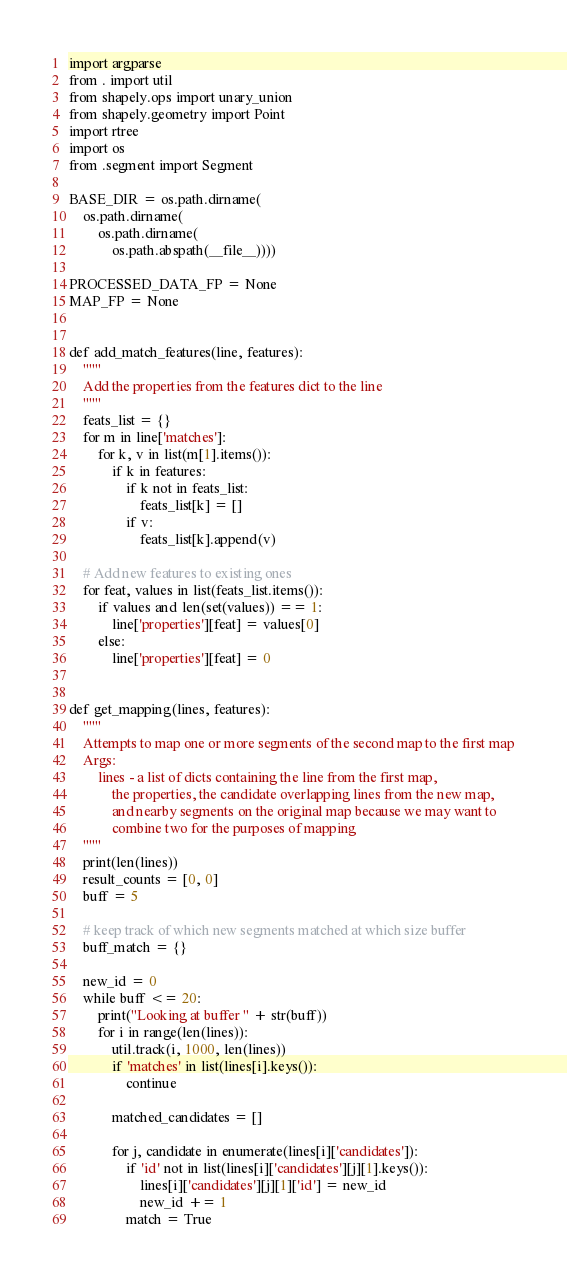<code> <loc_0><loc_0><loc_500><loc_500><_Python_>import argparse
from . import util
from shapely.ops import unary_union
from shapely.geometry import Point
import rtree
import os
from .segment import Segment

BASE_DIR = os.path.dirname(
    os.path.dirname(
        os.path.dirname(
            os.path.abspath(__file__))))

PROCESSED_DATA_FP = None
MAP_FP = None


def add_match_features(line, features):
    """
    Add the properties from the features dict to the line
    """
    feats_list = {}
    for m in line['matches']:
        for k, v in list(m[1].items()):
            if k in features:
                if k not in feats_list:
                    feats_list[k] = []
                if v:
                    feats_list[k].append(v)

    # Add new features to existing ones
    for feat, values in list(feats_list.items()):
        if values and len(set(values)) == 1:
            line['properties'][feat] = values[0]
        else:
            line['properties'][feat] = 0


def get_mapping(lines, features):
    """
    Attempts to map one or more segments of the second map to the first map
    Args:
        lines - a list of dicts containing the line from the first map,
            the properties, the candidate overlapping lines from the new map,
            and nearby segments on the original map because we may want to
            combine two for the purposes of mapping
    """
    print(len(lines))
    result_counts = [0, 0]
    buff = 5

    # keep track of which new segments matched at which size buffer
    buff_match = {}

    new_id = 0
    while buff <= 20:
        print("Looking at buffer " + str(buff))
        for i in range(len(lines)):
            util.track(i, 1000, len(lines))
            if 'matches' in list(lines[i].keys()):
                continue

            matched_candidates = []

            for j, candidate in enumerate(lines[i]['candidates']):
                if 'id' not in list(lines[i]['candidates'][j][1].keys()):
                    lines[i]['candidates'][j][1]['id'] = new_id
                    new_id += 1
                match = True
</code> 